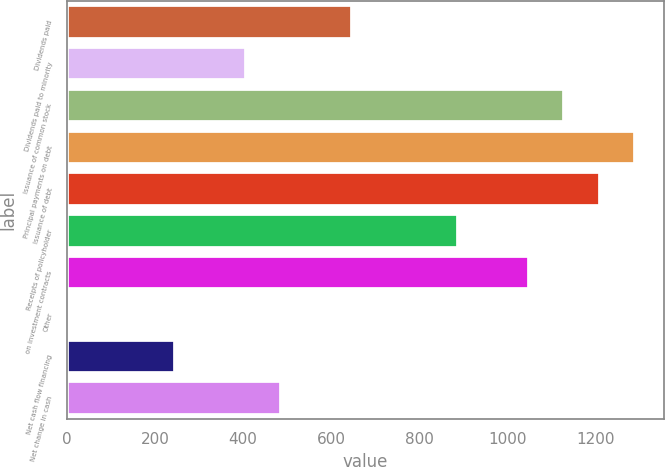Convert chart to OTSL. <chart><loc_0><loc_0><loc_500><loc_500><bar_chart><fcel>Dividends paid<fcel>Dividends paid to minority<fcel>Issuance of common stock<fcel>Principal payments on debt<fcel>Issuance of debt<fcel>Receipts of policyholder<fcel>on investment contracts<fcel>Other<fcel>Net cash flow financing<fcel>Net change in cash<nl><fcel>646.76<fcel>405.65<fcel>1128.98<fcel>1289.72<fcel>1209.35<fcel>887.87<fcel>1048.61<fcel>3.8<fcel>244.91<fcel>486.02<nl></chart> 